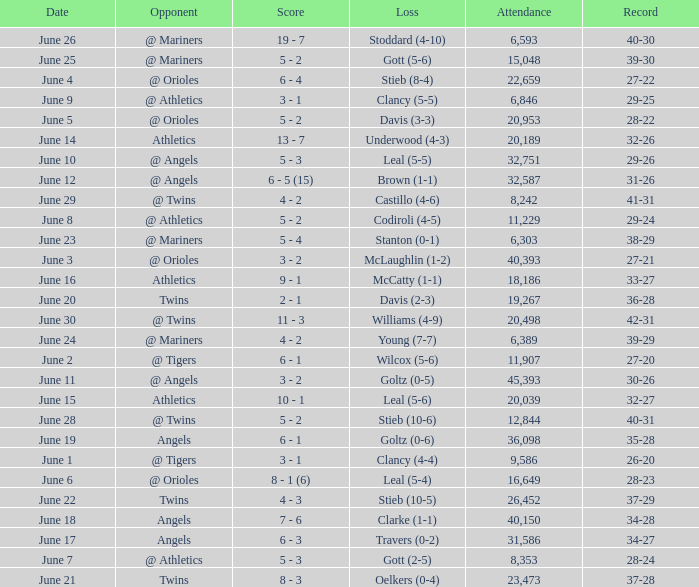What was the record for the date of June 14? 32-26. 